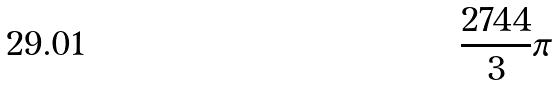Convert formula to latex. <formula><loc_0><loc_0><loc_500><loc_500>\frac { 2 7 4 4 } { 3 } \pi</formula> 